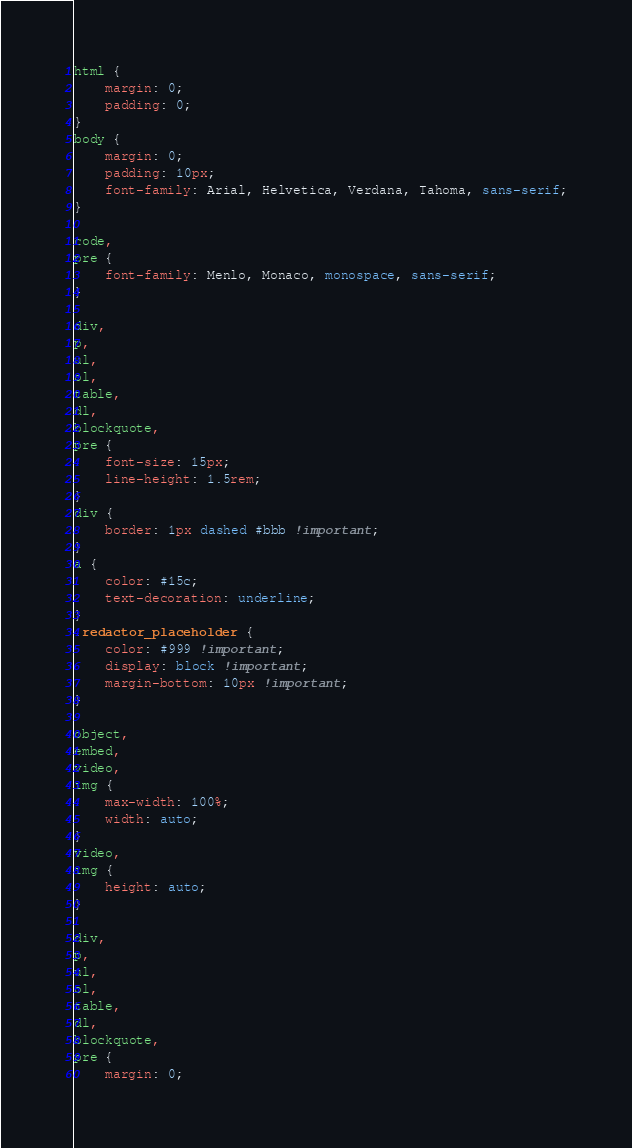<code> <loc_0><loc_0><loc_500><loc_500><_CSS_>html {
	margin: 0;
	padding: 0;
}
body {
	margin: 0;
	padding: 10px;
	font-family: Arial, Helvetica, Verdana, Tahoma, sans-serif;
}

code,
pre {
	font-family: Menlo, Monaco, monospace, sans-serif;
}

div,
p,
ul,
ol,
table,
dl,
blockquote,
pre {
	font-size: 15px;
	line-height: 1.5rem;
}
div {
	border: 1px dashed #bbb !important;
}
a {
	color: #15c;
	text-decoration: underline;
}
.redactor_placeholder {
	color: #999 !important;
	display: block !important;
	margin-bottom: 10px !important;
}

object,
embed,
video,
img {
	max-width: 100%;
	width: auto;
}
video,
img {
	height: auto;
}

div,
p,
ul,
ol,
table,
dl,
blockquote,
pre {
	margin: 0;</code> 